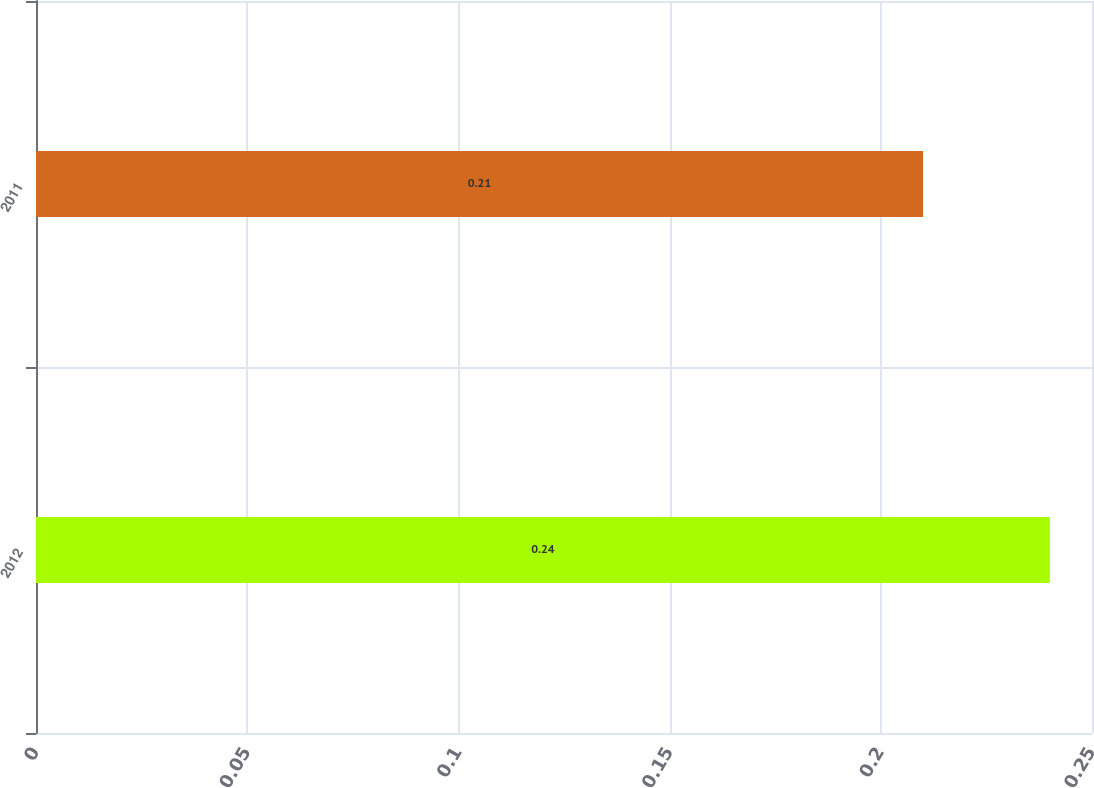Convert chart. <chart><loc_0><loc_0><loc_500><loc_500><bar_chart><fcel>2012<fcel>2011<nl><fcel>0.24<fcel>0.21<nl></chart> 